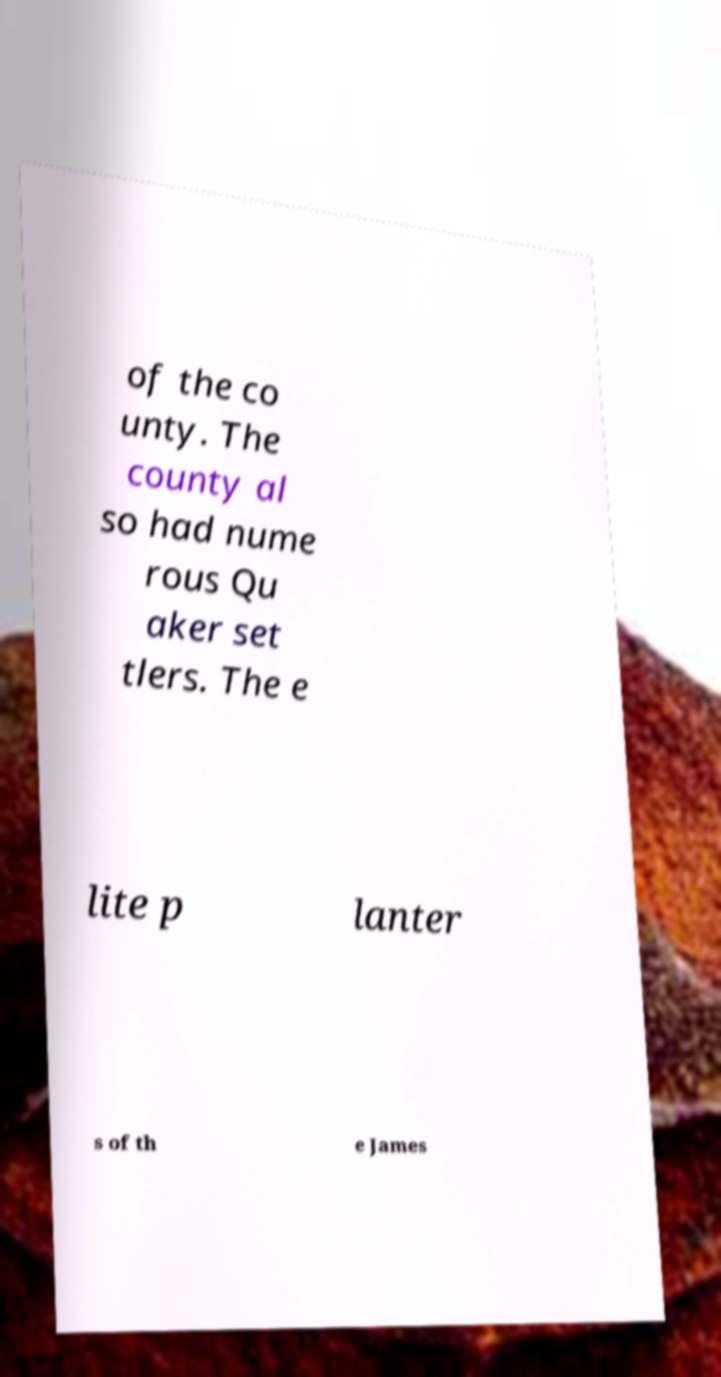There's text embedded in this image that I need extracted. Can you transcribe it verbatim? of the co unty. The county al so had nume rous Qu aker set tlers. The e lite p lanter s of th e James 